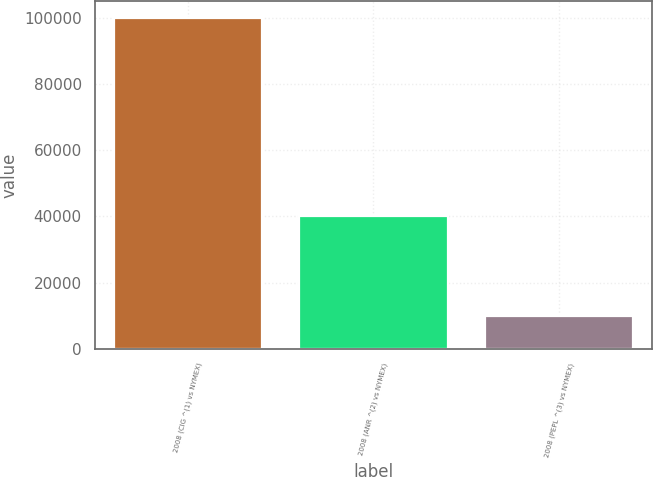Convert chart. <chart><loc_0><loc_0><loc_500><loc_500><bar_chart><fcel>2008 (CIG ^(1) vs NYMEX)<fcel>2008 (ANR ^(2) vs NYMEX)<fcel>2008 (PEPL ^(3) vs NYMEX)<nl><fcel>100000<fcel>40000<fcel>10000<nl></chart> 